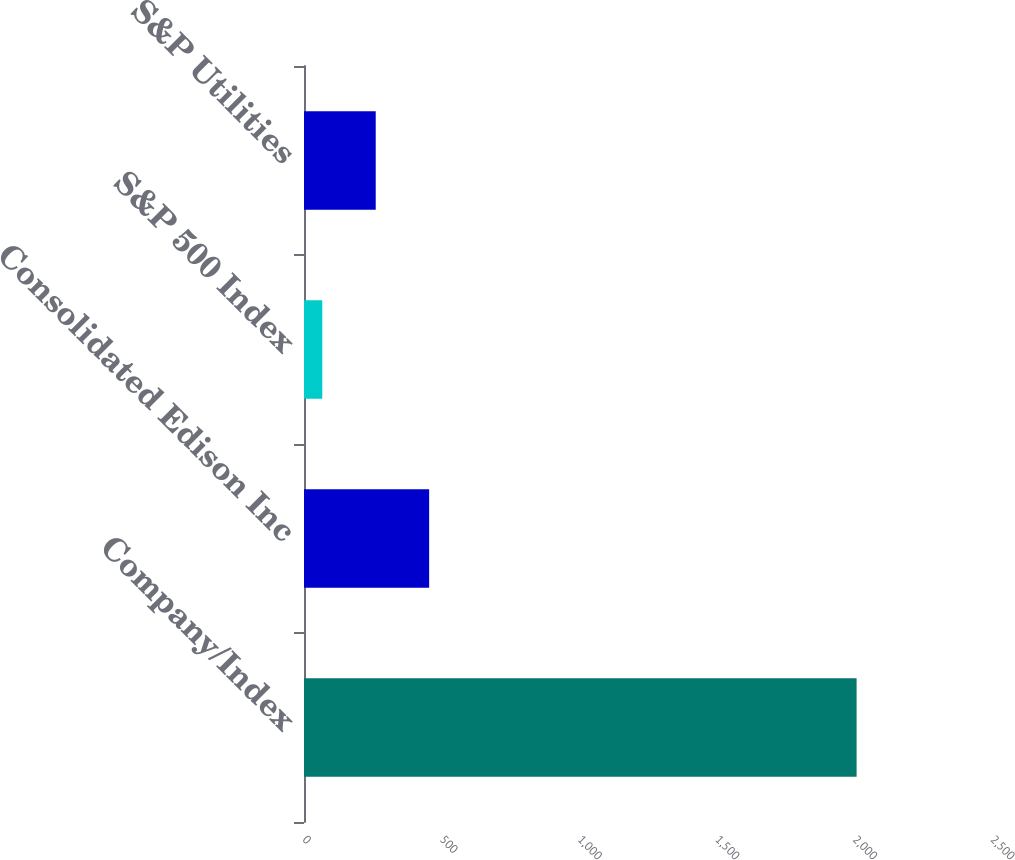Convert chart. <chart><loc_0><loc_0><loc_500><loc_500><bar_chart><fcel>Company/Index<fcel>Consolidated Edison Inc<fcel>S&P 500 Index<fcel>S&P Utilities<nl><fcel>2008<fcel>454.76<fcel>66.46<fcel>260.61<nl></chart> 